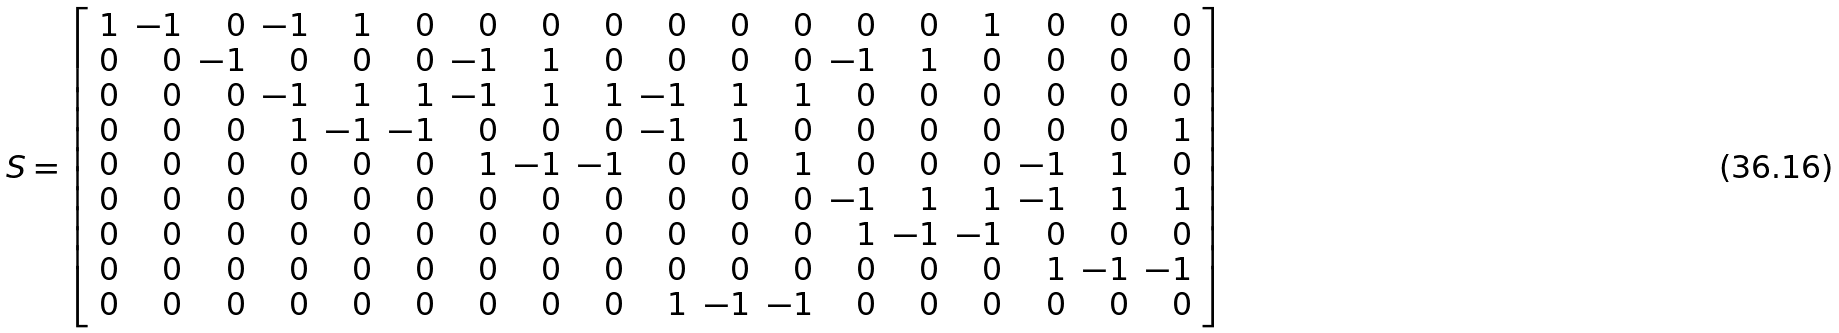<formula> <loc_0><loc_0><loc_500><loc_500>S = \left [ \begin{array} { r r r r r r r r r r r r r r r r r r } 1 & - 1 & 0 & - 1 & 1 & 0 & 0 & 0 & 0 & 0 & 0 & 0 & 0 & 0 & 1 & 0 & 0 & 0 \\ 0 & 0 & - 1 & 0 & 0 & 0 & - 1 & 1 & 0 & 0 & 0 & 0 & - 1 & 1 & 0 & 0 & 0 & 0 \\ 0 & 0 & 0 & - 1 & 1 & 1 & - 1 & 1 & 1 & - 1 & 1 & 1 & 0 & 0 & 0 & 0 & 0 & 0 \\ 0 & 0 & 0 & 1 & - 1 & - 1 & 0 & 0 & 0 & - 1 & 1 & 0 & 0 & 0 & 0 & 0 & 0 & 1 \\ 0 & 0 & 0 & 0 & 0 & 0 & 1 & - 1 & - 1 & 0 & 0 & 1 & 0 & 0 & 0 & - 1 & 1 & 0 \\ 0 & 0 & 0 & 0 & 0 & 0 & 0 & 0 & 0 & 0 & 0 & 0 & - 1 & 1 & 1 & - 1 & 1 & 1 \\ 0 & 0 & 0 & 0 & 0 & 0 & 0 & 0 & 0 & 0 & 0 & 0 & 1 & - 1 & - 1 & 0 & 0 & 0 \\ 0 & 0 & 0 & 0 & 0 & 0 & 0 & 0 & 0 & 0 & 0 & 0 & 0 & 0 & 0 & 1 & - 1 & - 1 \\ 0 & 0 & 0 & 0 & 0 & 0 & 0 & 0 & 0 & 1 & - 1 & - 1 & 0 & 0 & 0 & 0 & 0 & 0 \end{array} \right ]</formula> 